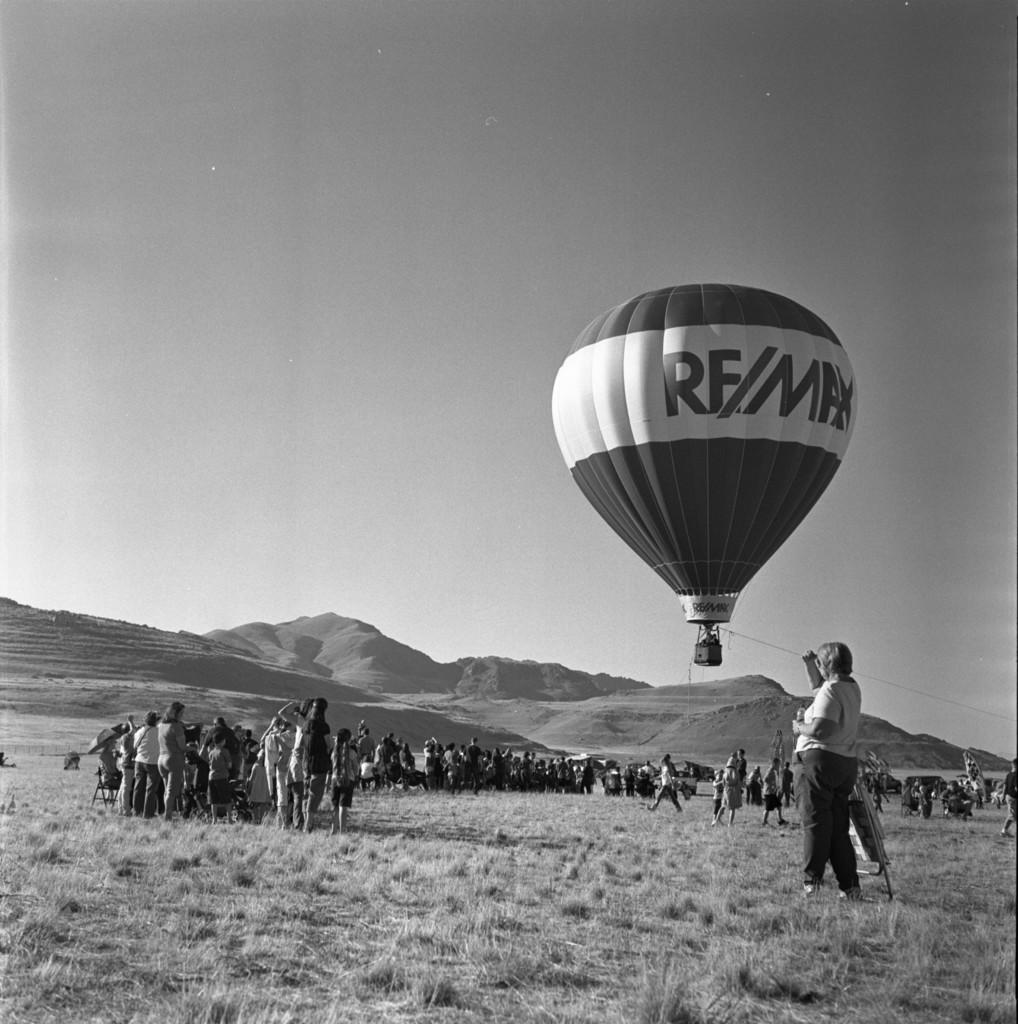What object is present in the image that is typically filled with air? There is a balloon in the image. Who or what can be seen in the image besides the balloon? There are people standing in the image. What type of ground surface is visible in the image? There is grass visible in the image. What part of the natural environment is visible in the image? The sky is visible in the image. What type of breakfast is being advertised in the image? There is no breakfast or advertisement present in the image; it features a balloon, people, grass, and the sky. 